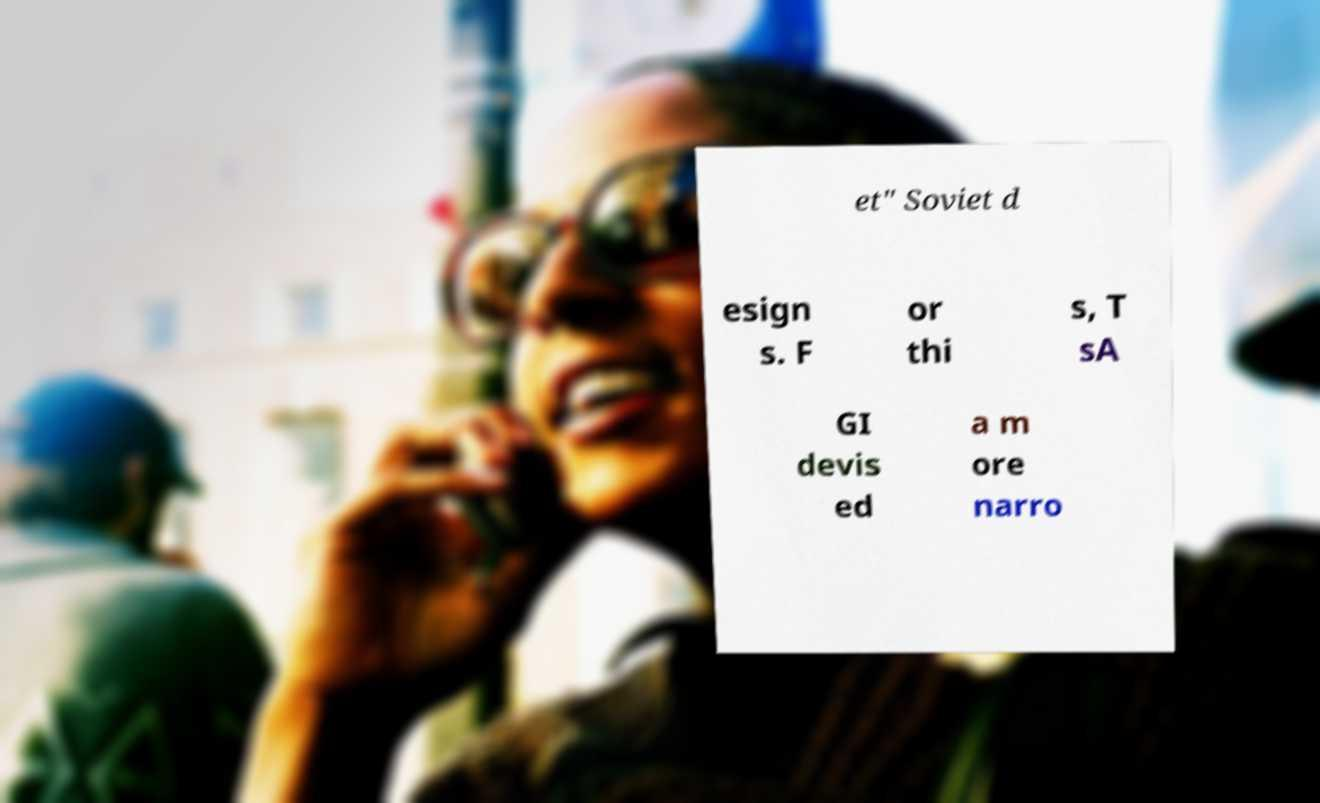Please identify and transcribe the text found in this image. et" Soviet d esign s. F or thi s, T sA GI devis ed a m ore narro 